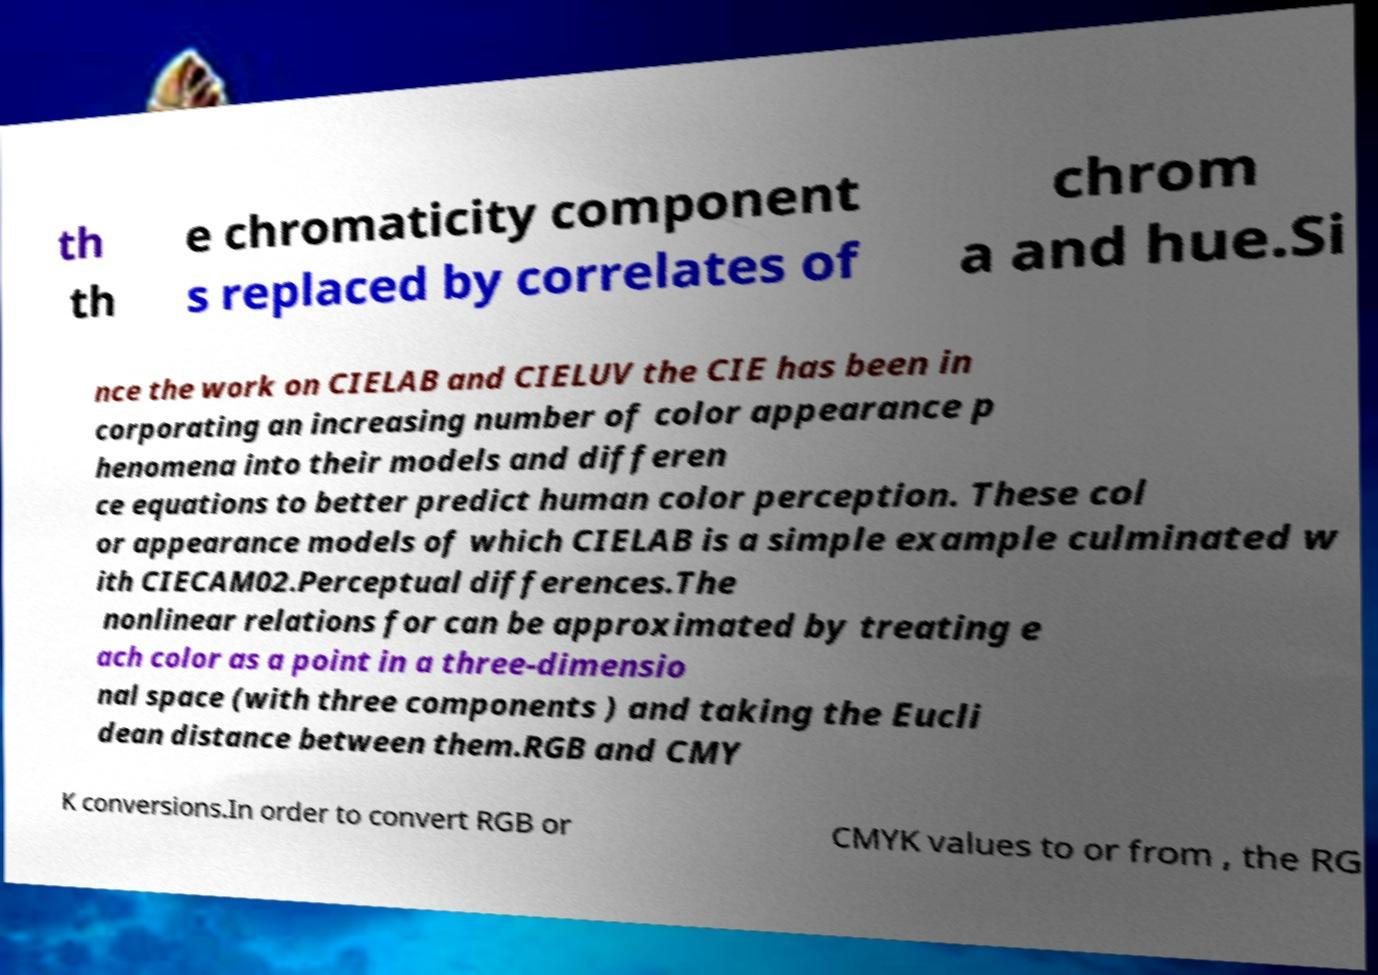Could you assist in decoding the text presented in this image and type it out clearly? th th e chromaticity component s replaced by correlates of chrom a and hue.Si nce the work on CIELAB and CIELUV the CIE has been in corporating an increasing number of color appearance p henomena into their models and differen ce equations to better predict human color perception. These col or appearance models of which CIELAB is a simple example culminated w ith CIECAM02.Perceptual differences.The nonlinear relations for can be approximated by treating e ach color as a point in a three-dimensio nal space (with three components ) and taking the Eucli dean distance between them.RGB and CMY K conversions.In order to convert RGB or CMYK values to or from , the RG 